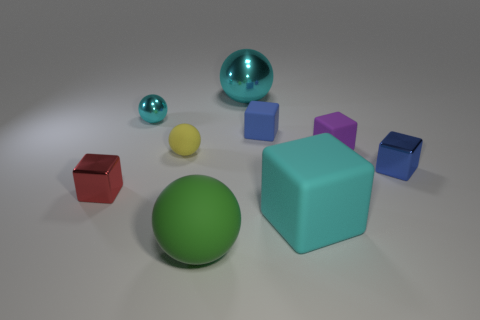The yellow thing is what shape? sphere 